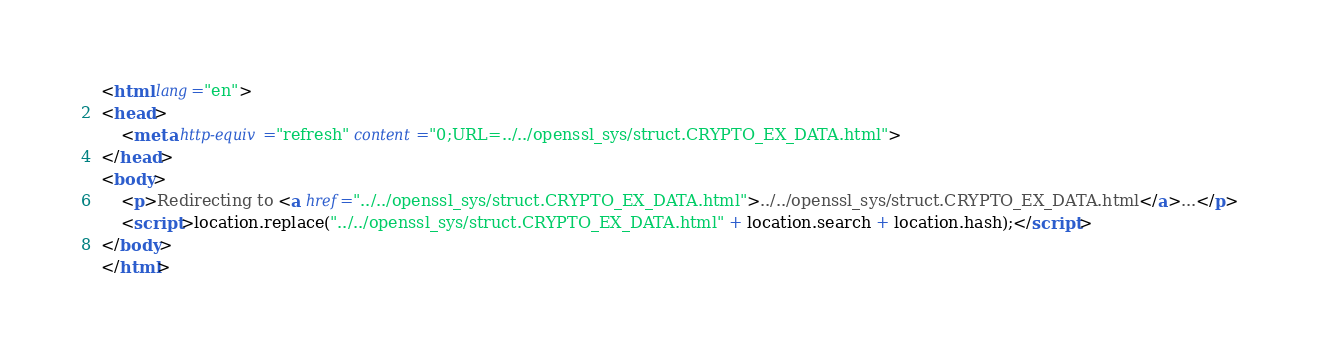Convert code to text. <code><loc_0><loc_0><loc_500><loc_500><_HTML_><html lang="en">
<head>
    <meta http-equiv="refresh" content="0;URL=../../openssl_sys/struct.CRYPTO_EX_DATA.html">
</head>
<body>
    <p>Redirecting to <a href="../../openssl_sys/struct.CRYPTO_EX_DATA.html">../../openssl_sys/struct.CRYPTO_EX_DATA.html</a>...</p>
    <script>location.replace("../../openssl_sys/struct.CRYPTO_EX_DATA.html" + location.search + location.hash);</script>
</body>
</html></code> 